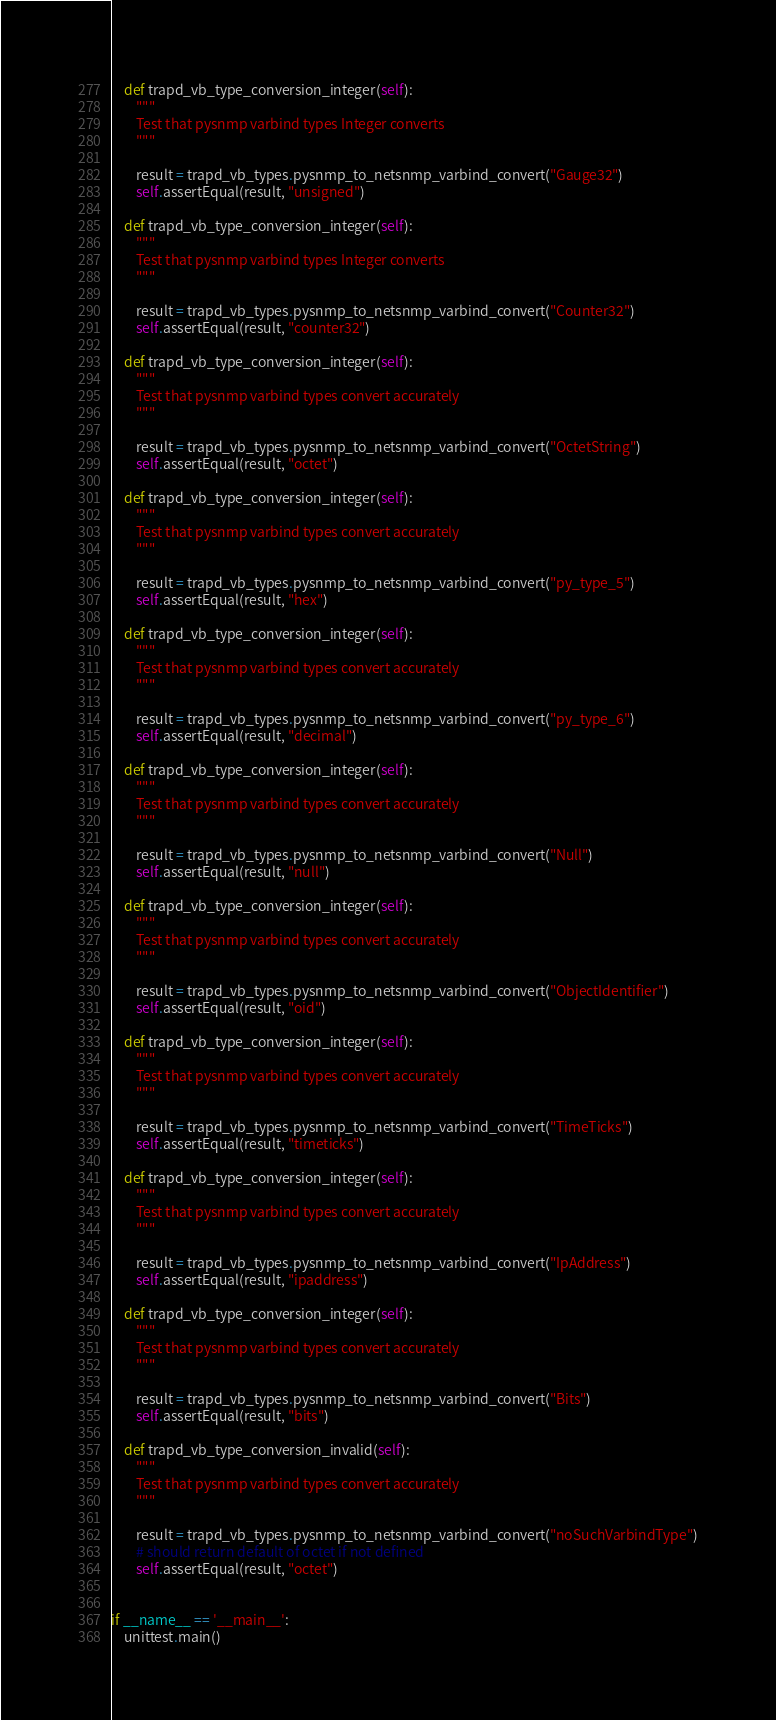Convert code to text. <code><loc_0><loc_0><loc_500><loc_500><_Python_>    def trapd_vb_type_conversion_integer(self):
        """
        Test that pysnmp varbind types Integer converts
        """

        result = trapd_vb_types.pysnmp_to_netsnmp_varbind_convert("Gauge32")
        self.assertEqual(result, "unsigned")

    def trapd_vb_type_conversion_integer(self):
        """
        Test that pysnmp varbind types Integer converts
        """

        result = trapd_vb_types.pysnmp_to_netsnmp_varbind_convert("Counter32")
        self.assertEqual(result, "counter32")

    def trapd_vb_type_conversion_integer(self):
        """
        Test that pysnmp varbind types convert accurately
        """

        result = trapd_vb_types.pysnmp_to_netsnmp_varbind_convert("OctetString")
        self.assertEqual(result, "octet")

    def trapd_vb_type_conversion_integer(self):
        """
        Test that pysnmp varbind types convert accurately
        """

        result = trapd_vb_types.pysnmp_to_netsnmp_varbind_convert("py_type_5")
        self.assertEqual(result, "hex")

    def trapd_vb_type_conversion_integer(self):
        """
        Test that pysnmp varbind types convert accurately
        """

        result = trapd_vb_types.pysnmp_to_netsnmp_varbind_convert("py_type_6")
        self.assertEqual(result, "decimal")

    def trapd_vb_type_conversion_integer(self):
        """
        Test that pysnmp varbind types convert accurately
        """

        result = trapd_vb_types.pysnmp_to_netsnmp_varbind_convert("Null")
        self.assertEqual(result, "null")

    def trapd_vb_type_conversion_integer(self):
        """
        Test that pysnmp varbind types convert accurately
        """

        result = trapd_vb_types.pysnmp_to_netsnmp_varbind_convert("ObjectIdentifier")
        self.assertEqual(result, "oid")

    def trapd_vb_type_conversion_integer(self):
        """
        Test that pysnmp varbind types convert accurately
        """

        result = trapd_vb_types.pysnmp_to_netsnmp_varbind_convert("TimeTicks")
        self.assertEqual(result, "timeticks")

    def trapd_vb_type_conversion_integer(self):
        """
        Test that pysnmp varbind types convert accurately
        """

        result = trapd_vb_types.pysnmp_to_netsnmp_varbind_convert("IpAddress")
        self.assertEqual(result, "ipaddress")

    def trapd_vb_type_conversion_integer(self):
        """
        Test that pysnmp varbind types convert accurately
        """

        result = trapd_vb_types.pysnmp_to_netsnmp_varbind_convert("Bits")
        self.assertEqual(result, "bits")

    def trapd_vb_type_conversion_invalid(self):
        """
        Test that pysnmp varbind types convert accurately
        """

        result = trapd_vb_types.pysnmp_to_netsnmp_varbind_convert("noSuchVarbindType")
        # should return default of octet if not defined
        self.assertEqual(result, "octet")

 
if __name__ == '__main__':
    unittest.main()
</code> 